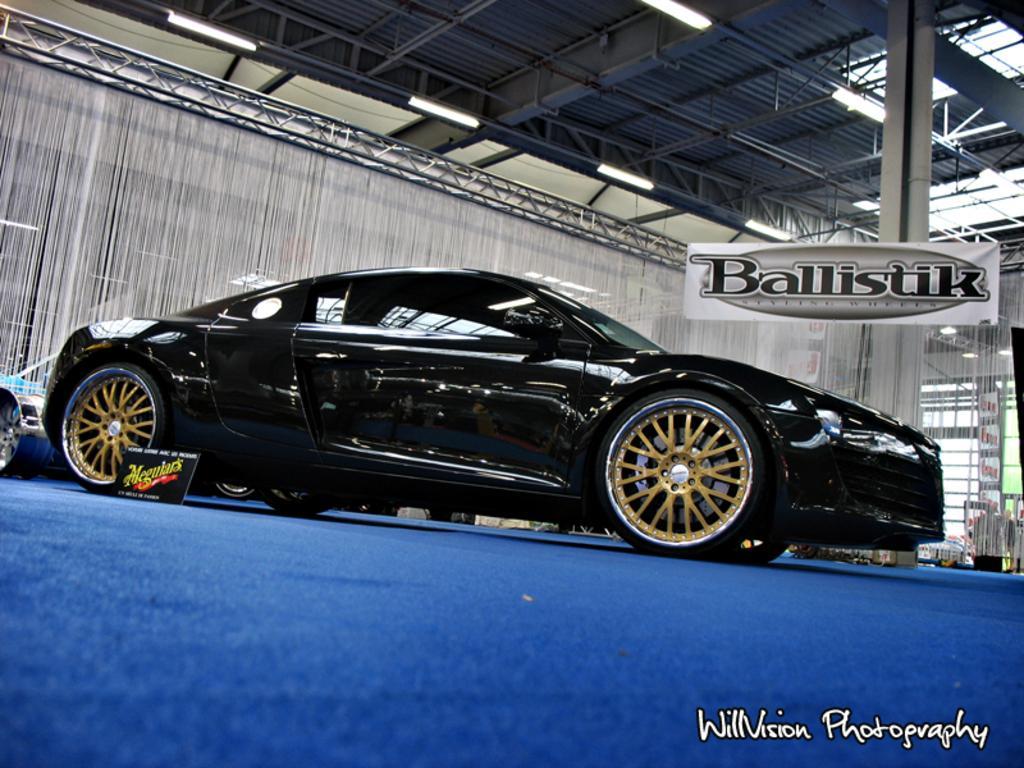In one or two sentences, can you explain what this image depicts? In this image I can see in the middle there is a car in black color, at the bottom there is the blue color floor mat. On the right side it looks like a board in white color, at the top there are lights. In the right hand side bottom there is the name. 